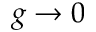<formula> <loc_0><loc_0><loc_500><loc_500>g \to 0</formula> 